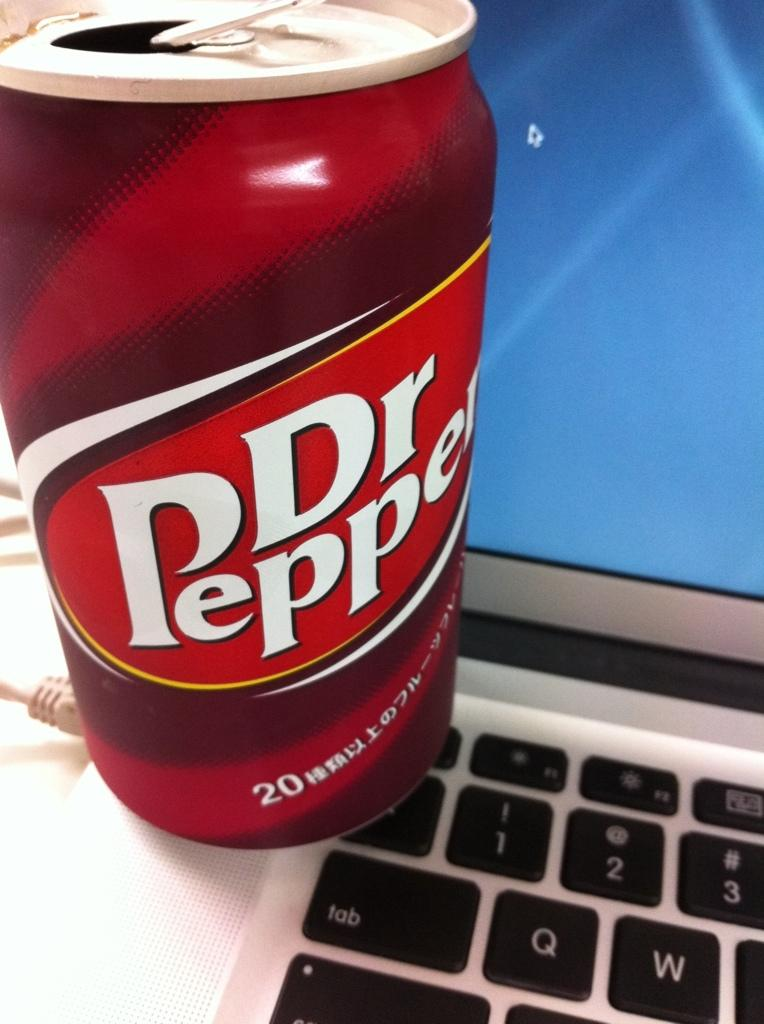<image>
Present a compact description of the photo's key features. A can of Dr. Pepper sitting on the keyboard of a laptop. 